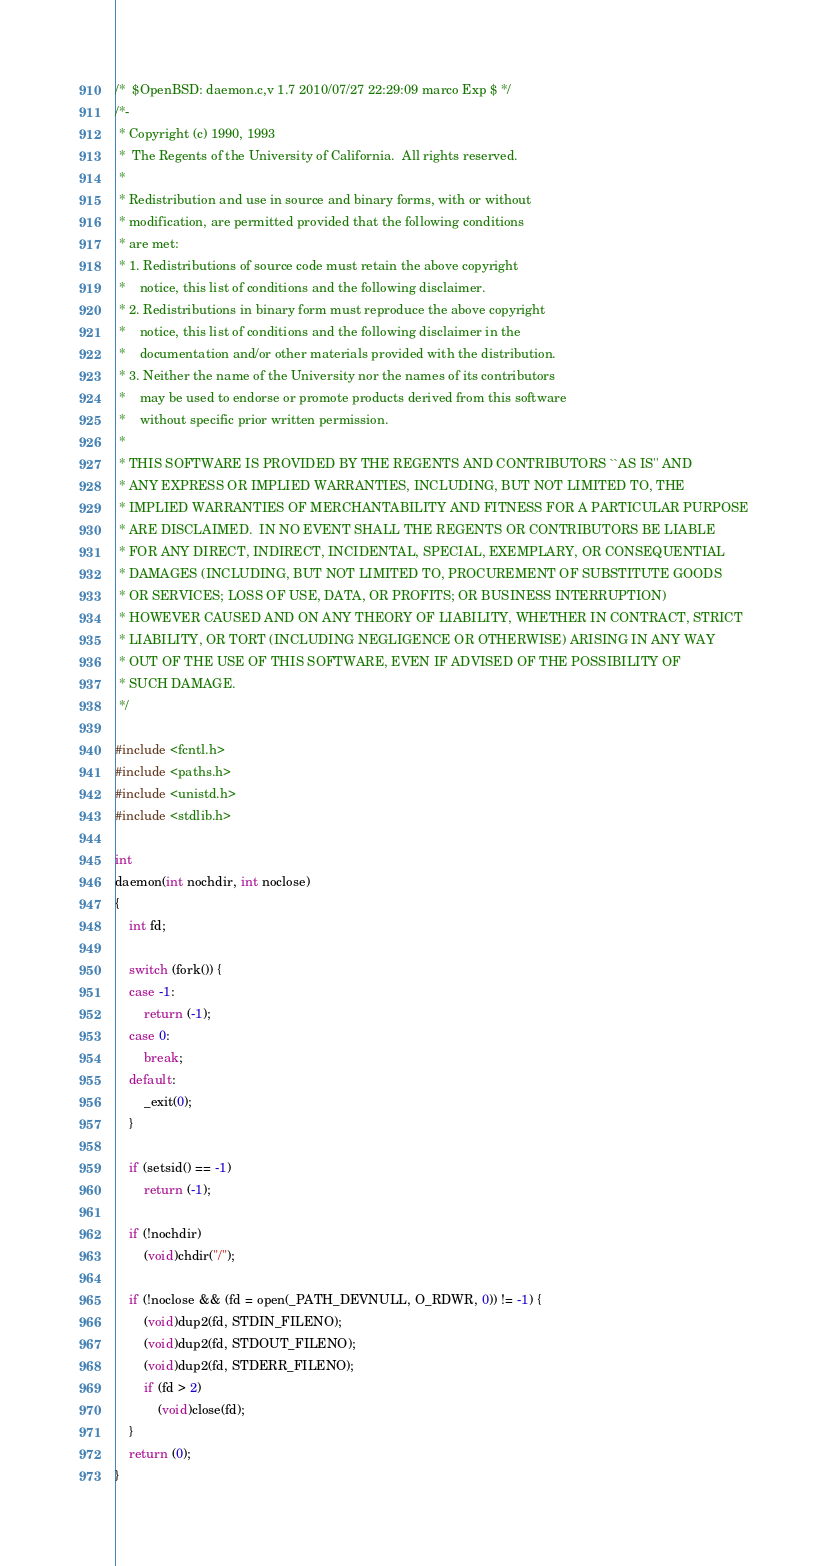Convert code to text. <code><loc_0><loc_0><loc_500><loc_500><_C_>/*	$OpenBSD: daemon.c,v 1.7 2010/07/27 22:29:09 marco Exp $ */
/*-
 * Copyright (c) 1990, 1993
 *	The Regents of the University of California.  All rights reserved.
 *
 * Redistribution and use in source and binary forms, with or without
 * modification, are permitted provided that the following conditions
 * are met:
 * 1. Redistributions of source code must retain the above copyright
 *    notice, this list of conditions and the following disclaimer.
 * 2. Redistributions in binary form must reproduce the above copyright
 *    notice, this list of conditions and the following disclaimer in the
 *    documentation and/or other materials provided with the distribution.
 * 3. Neither the name of the University nor the names of its contributors
 *    may be used to endorse or promote products derived from this software
 *    without specific prior written permission.
 *
 * THIS SOFTWARE IS PROVIDED BY THE REGENTS AND CONTRIBUTORS ``AS IS'' AND
 * ANY EXPRESS OR IMPLIED WARRANTIES, INCLUDING, BUT NOT LIMITED TO, THE
 * IMPLIED WARRANTIES OF MERCHANTABILITY AND FITNESS FOR A PARTICULAR PURPOSE
 * ARE DISCLAIMED.  IN NO EVENT SHALL THE REGENTS OR CONTRIBUTORS BE LIABLE
 * FOR ANY DIRECT, INDIRECT, INCIDENTAL, SPECIAL, EXEMPLARY, OR CONSEQUENTIAL
 * DAMAGES (INCLUDING, BUT NOT LIMITED TO, PROCUREMENT OF SUBSTITUTE GOODS
 * OR SERVICES; LOSS OF USE, DATA, OR PROFITS; OR BUSINESS INTERRUPTION)
 * HOWEVER CAUSED AND ON ANY THEORY OF LIABILITY, WHETHER IN CONTRACT, STRICT
 * LIABILITY, OR TORT (INCLUDING NEGLIGENCE OR OTHERWISE) ARISING IN ANY WAY
 * OUT OF THE USE OF THIS SOFTWARE, EVEN IF ADVISED OF THE POSSIBILITY OF
 * SUCH DAMAGE.
 */

#include <fcntl.h>
#include <paths.h>
#include <unistd.h>
#include <stdlib.h>

int
daemon(int nochdir, int noclose)
{
	int fd;

	switch (fork()) {
	case -1:
		return (-1);
	case 0:
		break;
	default:
		_exit(0);
	}

	if (setsid() == -1)
		return (-1);

	if (!nochdir)
		(void)chdir("/");

	if (!noclose && (fd = open(_PATH_DEVNULL, O_RDWR, 0)) != -1) {
		(void)dup2(fd, STDIN_FILENO);
		(void)dup2(fd, STDOUT_FILENO);
		(void)dup2(fd, STDERR_FILENO);
		if (fd > 2)
			(void)close(fd);
	}
	return (0);
}
</code> 